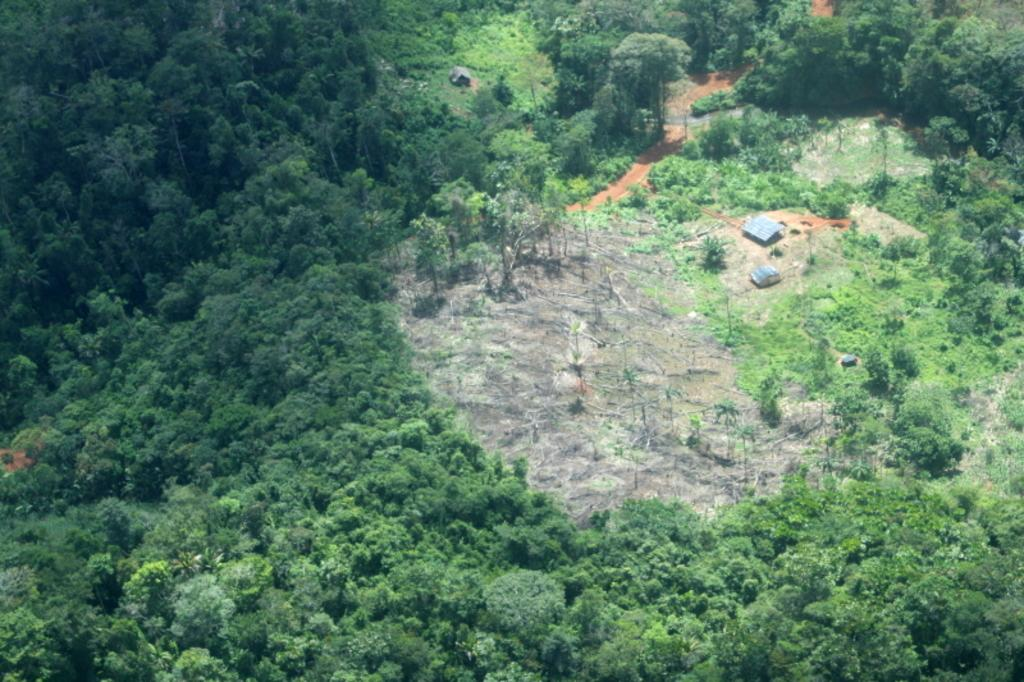What type of vegetation can be seen in the image? There is thicket in the image. What type of structures are present in the image? There are huts in the image. What is visible beneath the thicket and huts? The ground is visible in the image. Is there a party happening in the image? There is no indication of a party in the image; it features thicket, huts, and the ground. Can you see the person's aunt in the image? There is no person or any individual mentioned in the image, so it is not possible to identify an aunt. 